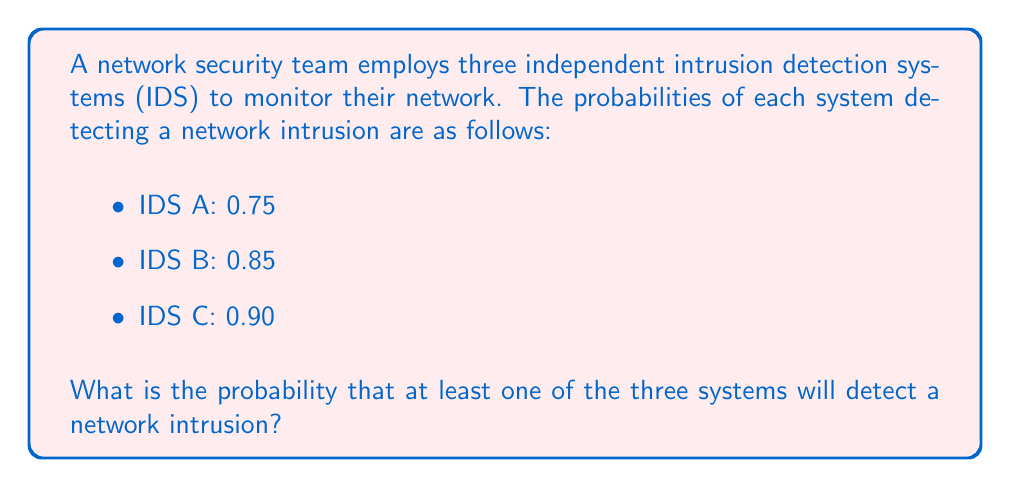Can you solve this math problem? Let's approach this step-by-step using the concept of probability of complementary events:

1) First, let's define our events:
   A: IDS A detects the intrusion
   B: IDS B detects the intrusion
   C: IDS C detects the intrusion

2) We want to find P(at least one system detects) = 1 - P(no system detects)

3) P(no system detects) = P(A' ∩ B' ∩ C'), where X' denotes the complement of event X

4) Since the systems are independent, we can multiply the individual probabilities:

   P(A' ∩ B' ∩ C') = P(A') * P(B') * P(C')

5) We know:
   P(A) = 0.75, so P(A') = 1 - 0.75 = 0.25
   P(B) = 0.85, so P(B') = 1 - 0.85 = 0.15
   P(C) = 0.90, so P(C') = 1 - 0.90 = 0.10

6) Substituting these values:

   P(no system detects) = 0.25 * 0.15 * 0.10 = 0.00375

7) Therefore, the probability that at least one system detects is:

   P(at least one system detects) = 1 - P(no system detects)
                                   = 1 - 0.00375
                                   = 0.99625

8) This can be expressed as a percentage: 99.625%
Answer: 0.99625 or 99.625% 